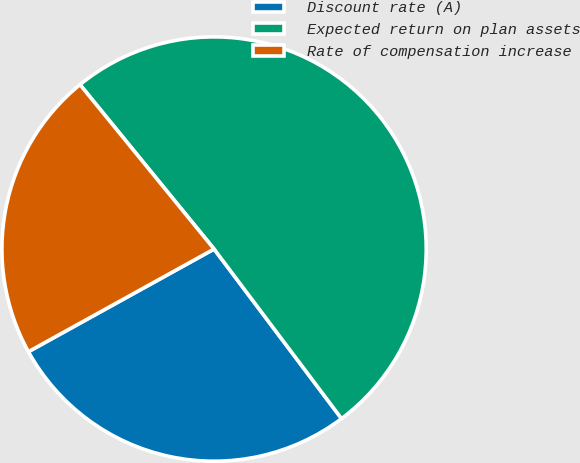Convert chart. <chart><loc_0><loc_0><loc_500><loc_500><pie_chart><fcel>Discount rate (A)<fcel>Expected return on plan assets<fcel>Rate of compensation increase<nl><fcel>27.22%<fcel>50.63%<fcel>22.15%<nl></chart> 